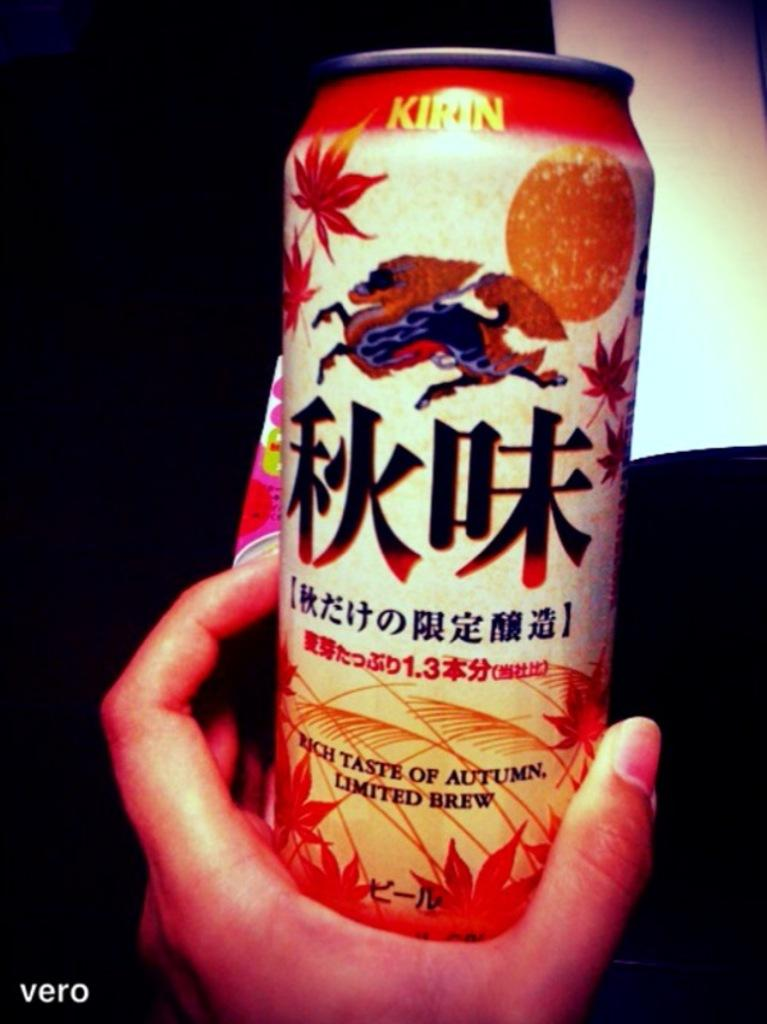What is the person's hand holding in the image? There is a person's hand holding a can in the image. What can be seen on the can? There is a label on the can. How would you describe the overall lighting in the image? The background of the image is dark. What type of vacation is the person's sister planning based on the image? There is no information about a vacation or the person's sister in the image, so it cannot be determined from the image. 